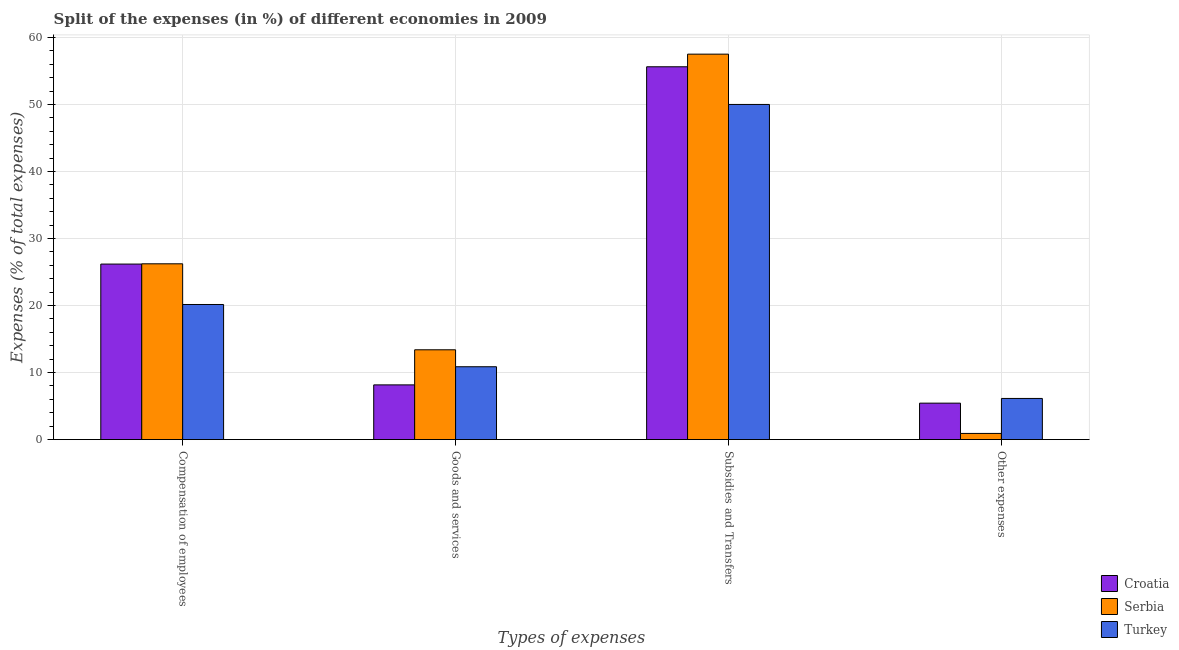How many different coloured bars are there?
Offer a very short reply. 3. Are the number of bars per tick equal to the number of legend labels?
Offer a very short reply. Yes. Are the number of bars on each tick of the X-axis equal?
Your answer should be very brief. Yes. What is the label of the 1st group of bars from the left?
Your response must be concise. Compensation of employees. What is the percentage of amount spent on compensation of employees in Turkey?
Your answer should be very brief. 20.16. Across all countries, what is the maximum percentage of amount spent on compensation of employees?
Give a very brief answer. 26.23. Across all countries, what is the minimum percentage of amount spent on other expenses?
Give a very brief answer. 0.92. In which country was the percentage of amount spent on subsidies maximum?
Your answer should be compact. Serbia. What is the total percentage of amount spent on compensation of employees in the graph?
Your answer should be compact. 72.58. What is the difference between the percentage of amount spent on compensation of employees in Serbia and that in Croatia?
Offer a very short reply. 0.04. What is the difference between the percentage of amount spent on goods and services in Croatia and the percentage of amount spent on subsidies in Serbia?
Your answer should be compact. -49.35. What is the average percentage of amount spent on other expenses per country?
Your answer should be very brief. 4.17. What is the difference between the percentage of amount spent on other expenses and percentage of amount spent on compensation of employees in Turkey?
Offer a very short reply. -14.02. In how many countries, is the percentage of amount spent on other expenses greater than 30 %?
Your answer should be very brief. 0. What is the ratio of the percentage of amount spent on goods and services in Serbia to that in Croatia?
Make the answer very short. 1.64. Is the difference between the percentage of amount spent on goods and services in Turkey and Serbia greater than the difference between the percentage of amount spent on subsidies in Turkey and Serbia?
Offer a very short reply. Yes. What is the difference between the highest and the second highest percentage of amount spent on compensation of employees?
Give a very brief answer. 0.04. What is the difference between the highest and the lowest percentage of amount spent on goods and services?
Keep it short and to the point. 5.24. In how many countries, is the percentage of amount spent on other expenses greater than the average percentage of amount spent on other expenses taken over all countries?
Provide a succinct answer. 2. Is it the case that in every country, the sum of the percentage of amount spent on compensation of employees and percentage of amount spent on goods and services is greater than the sum of percentage of amount spent on subsidies and percentage of amount spent on other expenses?
Ensure brevity in your answer.  No. What does the 1st bar from the right in Subsidies and Transfers represents?
Provide a short and direct response. Turkey. Are all the bars in the graph horizontal?
Give a very brief answer. No. How many countries are there in the graph?
Offer a terse response. 3. Are the values on the major ticks of Y-axis written in scientific E-notation?
Ensure brevity in your answer.  No. What is the title of the graph?
Give a very brief answer. Split of the expenses (in %) of different economies in 2009. What is the label or title of the X-axis?
Provide a succinct answer. Types of expenses. What is the label or title of the Y-axis?
Give a very brief answer. Expenses (% of total expenses). What is the Expenses (% of total expenses) of Croatia in Compensation of employees?
Provide a short and direct response. 26.19. What is the Expenses (% of total expenses) of Serbia in Compensation of employees?
Keep it short and to the point. 26.23. What is the Expenses (% of total expenses) in Turkey in Compensation of employees?
Give a very brief answer. 20.16. What is the Expenses (% of total expenses) of Croatia in Goods and services?
Your answer should be very brief. 8.17. What is the Expenses (% of total expenses) in Serbia in Goods and services?
Offer a terse response. 13.4. What is the Expenses (% of total expenses) in Turkey in Goods and services?
Provide a succinct answer. 10.87. What is the Expenses (% of total expenses) in Croatia in Subsidies and Transfers?
Offer a terse response. 55.63. What is the Expenses (% of total expenses) in Serbia in Subsidies and Transfers?
Offer a terse response. 57.52. What is the Expenses (% of total expenses) in Turkey in Subsidies and Transfers?
Provide a succinct answer. 50.01. What is the Expenses (% of total expenses) of Croatia in Other expenses?
Offer a terse response. 5.44. What is the Expenses (% of total expenses) of Serbia in Other expenses?
Offer a terse response. 0.92. What is the Expenses (% of total expenses) in Turkey in Other expenses?
Offer a very short reply. 6.14. Across all Types of expenses, what is the maximum Expenses (% of total expenses) of Croatia?
Your response must be concise. 55.63. Across all Types of expenses, what is the maximum Expenses (% of total expenses) of Serbia?
Provide a succinct answer. 57.52. Across all Types of expenses, what is the maximum Expenses (% of total expenses) in Turkey?
Give a very brief answer. 50.01. Across all Types of expenses, what is the minimum Expenses (% of total expenses) of Croatia?
Your answer should be very brief. 5.44. Across all Types of expenses, what is the minimum Expenses (% of total expenses) of Serbia?
Provide a short and direct response. 0.92. Across all Types of expenses, what is the minimum Expenses (% of total expenses) of Turkey?
Ensure brevity in your answer.  6.14. What is the total Expenses (% of total expenses) of Croatia in the graph?
Make the answer very short. 95.43. What is the total Expenses (% of total expenses) in Serbia in the graph?
Offer a terse response. 98.07. What is the total Expenses (% of total expenses) in Turkey in the graph?
Your answer should be very brief. 87.19. What is the difference between the Expenses (% of total expenses) of Croatia in Compensation of employees and that in Goods and services?
Give a very brief answer. 18.03. What is the difference between the Expenses (% of total expenses) of Serbia in Compensation of employees and that in Goods and services?
Provide a succinct answer. 12.83. What is the difference between the Expenses (% of total expenses) in Turkey in Compensation of employees and that in Goods and services?
Your response must be concise. 9.29. What is the difference between the Expenses (% of total expenses) of Croatia in Compensation of employees and that in Subsidies and Transfers?
Your answer should be very brief. -29.44. What is the difference between the Expenses (% of total expenses) of Serbia in Compensation of employees and that in Subsidies and Transfers?
Ensure brevity in your answer.  -31.28. What is the difference between the Expenses (% of total expenses) of Turkey in Compensation of employees and that in Subsidies and Transfers?
Keep it short and to the point. -29.85. What is the difference between the Expenses (% of total expenses) in Croatia in Compensation of employees and that in Other expenses?
Ensure brevity in your answer.  20.75. What is the difference between the Expenses (% of total expenses) of Serbia in Compensation of employees and that in Other expenses?
Your answer should be compact. 25.31. What is the difference between the Expenses (% of total expenses) in Turkey in Compensation of employees and that in Other expenses?
Your answer should be compact. 14.02. What is the difference between the Expenses (% of total expenses) in Croatia in Goods and services and that in Subsidies and Transfers?
Make the answer very short. -47.47. What is the difference between the Expenses (% of total expenses) in Serbia in Goods and services and that in Subsidies and Transfers?
Your answer should be compact. -44.11. What is the difference between the Expenses (% of total expenses) of Turkey in Goods and services and that in Subsidies and Transfers?
Your answer should be compact. -39.14. What is the difference between the Expenses (% of total expenses) in Croatia in Goods and services and that in Other expenses?
Provide a short and direct response. 2.73. What is the difference between the Expenses (% of total expenses) in Serbia in Goods and services and that in Other expenses?
Your response must be concise. 12.48. What is the difference between the Expenses (% of total expenses) of Turkey in Goods and services and that in Other expenses?
Your response must be concise. 4.73. What is the difference between the Expenses (% of total expenses) of Croatia in Subsidies and Transfers and that in Other expenses?
Ensure brevity in your answer.  50.19. What is the difference between the Expenses (% of total expenses) in Serbia in Subsidies and Transfers and that in Other expenses?
Ensure brevity in your answer.  56.59. What is the difference between the Expenses (% of total expenses) in Turkey in Subsidies and Transfers and that in Other expenses?
Keep it short and to the point. 43.87. What is the difference between the Expenses (% of total expenses) in Croatia in Compensation of employees and the Expenses (% of total expenses) in Serbia in Goods and services?
Your answer should be compact. 12.79. What is the difference between the Expenses (% of total expenses) of Croatia in Compensation of employees and the Expenses (% of total expenses) of Turkey in Goods and services?
Keep it short and to the point. 15.32. What is the difference between the Expenses (% of total expenses) in Serbia in Compensation of employees and the Expenses (% of total expenses) in Turkey in Goods and services?
Give a very brief answer. 15.36. What is the difference between the Expenses (% of total expenses) in Croatia in Compensation of employees and the Expenses (% of total expenses) in Serbia in Subsidies and Transfers?
Make the answer very short. -31.32. What is the difference between the Expenses (% of total expenses) of Croatia in Compensation of employees and the Expenses (% of total expenses) of Turkey in Subsidies and Transfers?
Your answer should be very brief. -23.82. What is the difference between the Expenses (% of total expenses) in Serbia in Compensation of employees and the Expenses (% of total expenses) in Turkey in Subsidies and Transfers?
Provide a succinct answer. -23.78. What is the difference between the Expenses (% of total expenses) in Croatia in Compensation of employees and the Expenses (% of total expenses) in Serbia in Other expenses?
Give a very brief answer. 25.27. What is the difference between the Expenses (% of total expenses) of Croatia in Compensation of employees and the Expenses (% of total expenses) of Turkey in Other expenses?
Provide a short and direct response. 20.05. What is the difference between the Expenses (% of total expenses) of Serbia in Compensation of employees and the Expenses (% of total expenses) of Turkey in Other expenses?
Offer a very short reply. 20.09. What is the difference between the Expenses (% of total expenses) in Croatia in Goods and services and the Expenses (% of total expenses) in Serbia in Subsidies and Transfers?
Your answer should be compact. -49.35. What is the difference between the Expenses (% of total expenses) in Croatia in Goods and services and the Expenses (% of total expenses) in Turkey in Subsidies and Transfers?
Offer a very short reply. -41.85. What is the difference between the Expenses (% of total expenses) in Serbia in Goods and services and the Expenses (% of total expenses) in Turkey in Subsidies and Transfers?
Make the answer very short. -36.61. What is the difference between the Expenses (% of total expenses) in Croatia in Goods and services and the Expenses (% of total expenses) in Serbia in Other expenses?
Provide a succinct answer. 7.25. What is the difference between the Expenses (% of total expenses) in Croatia in Goods and services and the Expenses (% of total expenses) in Turkey in Other expenses?
Your response must be concise. 2.02. What is the difference between the Expenses (% of total expenses) in Serbia in Goods and services and the Expenses (% of total expenses) in Turkey in Other expenses?
Ensure brevity in your answer.  7.26. What is the difference between the Expenses (% of total expenses) in Croatia in Subsidies and Transfers and the Expenses (% of total expenses) in Serbia in Other expenses?
Your answer should be very brief. 54.71. What is the difference between the Expenses (% of total expenses) of Croatia in Subsidies and Transfers and the Expenses (% of total expenses) of Turkey in Other expenses?
Ensure brevity in your answer.  49.49. What is the difference between the Expenses (% of total expenses) in Serbia in Subsidies and Transfers and the Expenses (% of total expenses) in Turkey in Other expenses?
Ensure brevity in your answer.  51.37. What is the average Expenses (% of total expenses) in Croatia per Types of expenses?
Offer a very short reply. 23.86. What is the average Expenses (% of total expenses) in Serbia per Types of expenses?
Your answer should be very brief. 24.52. What is the average Expenses (% of total expenses) in Turkey per Types of expenses?
Offer a very short reply. 21.8. What is the difference between the Expenses (% of total expenses) of Croatia and Expenses (% of total expenses) of Serbia in Compensation of employees?
Your response must be concise. -0.04. What is the difference between the Expenses (% of total expenses) in Croatia and Expenses (% of total expenses) in Turkey in Compensation of employees?
Your answer should be compact. 6.03. What is the difference between the Expenses (% of total expenses) in Serbia and Expenses (% of total expenses) in Turkey in Compensation of employees?
Your answer should be very brief. 6.07. What is the difference between the Expenses (% of total expenses) in Croatia and Expenses (% of total expenses) in Serbia in Goods and services?
Ensure brevity in your answer.  -5.24. What is the difference between the Expenses (% of total expenses) of Croatia and Expenses (% of total expenses) of Turkey in Goods and services?
Ensure brevity in your answer.  -2.71. What is the difference between the Expenses (% of total expenses) in Serbia and Expenses (% of total expenses) in Turkey in Goods and services?
Ensure brevity in your answer.  2.53. What is the difference between the Expenses (% of total expenses) in Croatia and Expenses (% of total expenses) in Serbia in Subsidies and Transfers?
Your answer should be very brief. -1.88. What is the difference between the Expenses (% of total expenses) of Croatia and Expenses (% of total expenses) of Turkey in Subsidies and Transfers?
Offer a terse response. 5.62. What is the difference between the Expenses (% of total expenses) in Serbia and Expenses (% of total expenses) in Turkey in Subsidies and Transfers?
Ensure brevity in your answer.  7.5. What is the difference between the Expenses (% of total expenses) of Croatia and Expenses (% of total expenses) of Serbia in Other expenses?
Your answer should be compact. 4.52. What is the difference between the Expenses (% of total expenses) in Croatia and Expenses (% of total expenses) in Turkey in Other expenses?
Offer a very short reply. -0.7. What is the difference between the Expenses (% of total expenses) in Serbia and Expenses (% of total expenses) in Turkey in Other expenses?
Provide a succinct answer. -5.22. What is the ratio of the Expenses (% of total expenses) of Croatia in Compensation of employees to that in Goods and services?
Your response must be concise. 3.21. What is the ratio of the Expenses (% of total expenses) of Serbia in Compensation of employees to that in Goods and services?
Your answer should be very brief. 1.96. What is the ratio of the Expenses (% of total expenses) of Turkey in Compensation of employees to that in Goods and services?
Offer a terse response. 1.85. What is the ratio of the Expenses (% of total expenses) in Croatia in Compensation of employees to that in Subsidies and Transfers?
Ensure brevity in your answer.  0.47. What is the ratio of the Expenses (% of total expenses) of Serbia in Compensation of employees to that in Subsidies and Transfers?
Your answer should be very brief. 0.46. What is the ratio of the Expenses (% of total expenses) in Turkey in Compensation of employees to that in Subsidies and Transfers?
Give a very brief answer. 0.4. What is the ratio of the Expenses (% of total expenses) in Croatia in Compensation of employees to that in Other expenses?
Provide a short and direct response. 4.81. What is the ratio of the Expenses (% of total expenses) in Serbia in Compensation of employees to that in Other expenses?
Provide a succinct answer. 28.49. What is the ratio of the Expenses (% of total expenses) of Turkey in Compensation of employees to that in Other expenses?
Your answer should be very brief. 3.28. What is the ratio of the Expenses (% of total expenses) in Croatia in Goods and services to that in Subsidies and Transfers?
Your response must be concise. 0.15. What is the ratio of the Expenses (% of total expenses) of Serbia in Goods and services to that in Subsidies and Transfers?
Give a very brief answer. 0.23. What is the ratio of the Expenses (% of total expenses) of Turkey in Goods and services to that in Subsidies and Transfers?
Offer a terse response. 0.22. What is the ratio of the Expenses (% of total expenses) in Croatia in Goods and services to that in Other expenses?
Give a very brief answer. 1.5. What is the ratio of the Expenses (% of total expenses) in Serbia in Goods and services to that in Other expenses?
Your response must be concise. 14.56. What is the ratio of the Expenses (% of total expenses) of Turkey in Goods and services to that in Other expenses?
Make the answer very short. 1.77. What is the ratio of the Expenses (% of total expenses) of Croatia in Subsidies and Transfers to that in Other expenses?
Your answer should be very brief. 10.23. What is the ratio of the Expenses (% of total expenses) in Serbia in Subsidies and Transfers to that in Other expenses?
Ensure brevity in your answer.  62.46. What is the ratio of the Expenses (% of total expenses) in Turkey in Subsidies and Transfers to that in Other expenses?
Provide a succinct answer. 8.14. What is the difference between the highest and the second highest Expenses (% of total expenses) in Croatia?
Make the answer very short. 29.44. What is the difference between the highest and the second highest Expenses (% of total expenses) of Serbia?
Offer a terse response. 31.28. What is the difference between the highest and the second highest Expenses (% of total expenses) in Turkey?
Your response must be concise. 29.85. What is the difference between the highest and the lowest Expenses (% of total expenses) of Croatia?
Your response must be concise. 50.19. What is the difference between the highest and the lowest Expenses (% of total expenses) of Serbia?
Offer a terse response. 56.59. What is the difference between the highest and the lowest Expenses (% of total expenses) in Turkey?
Your response must be concise. 43.87. 